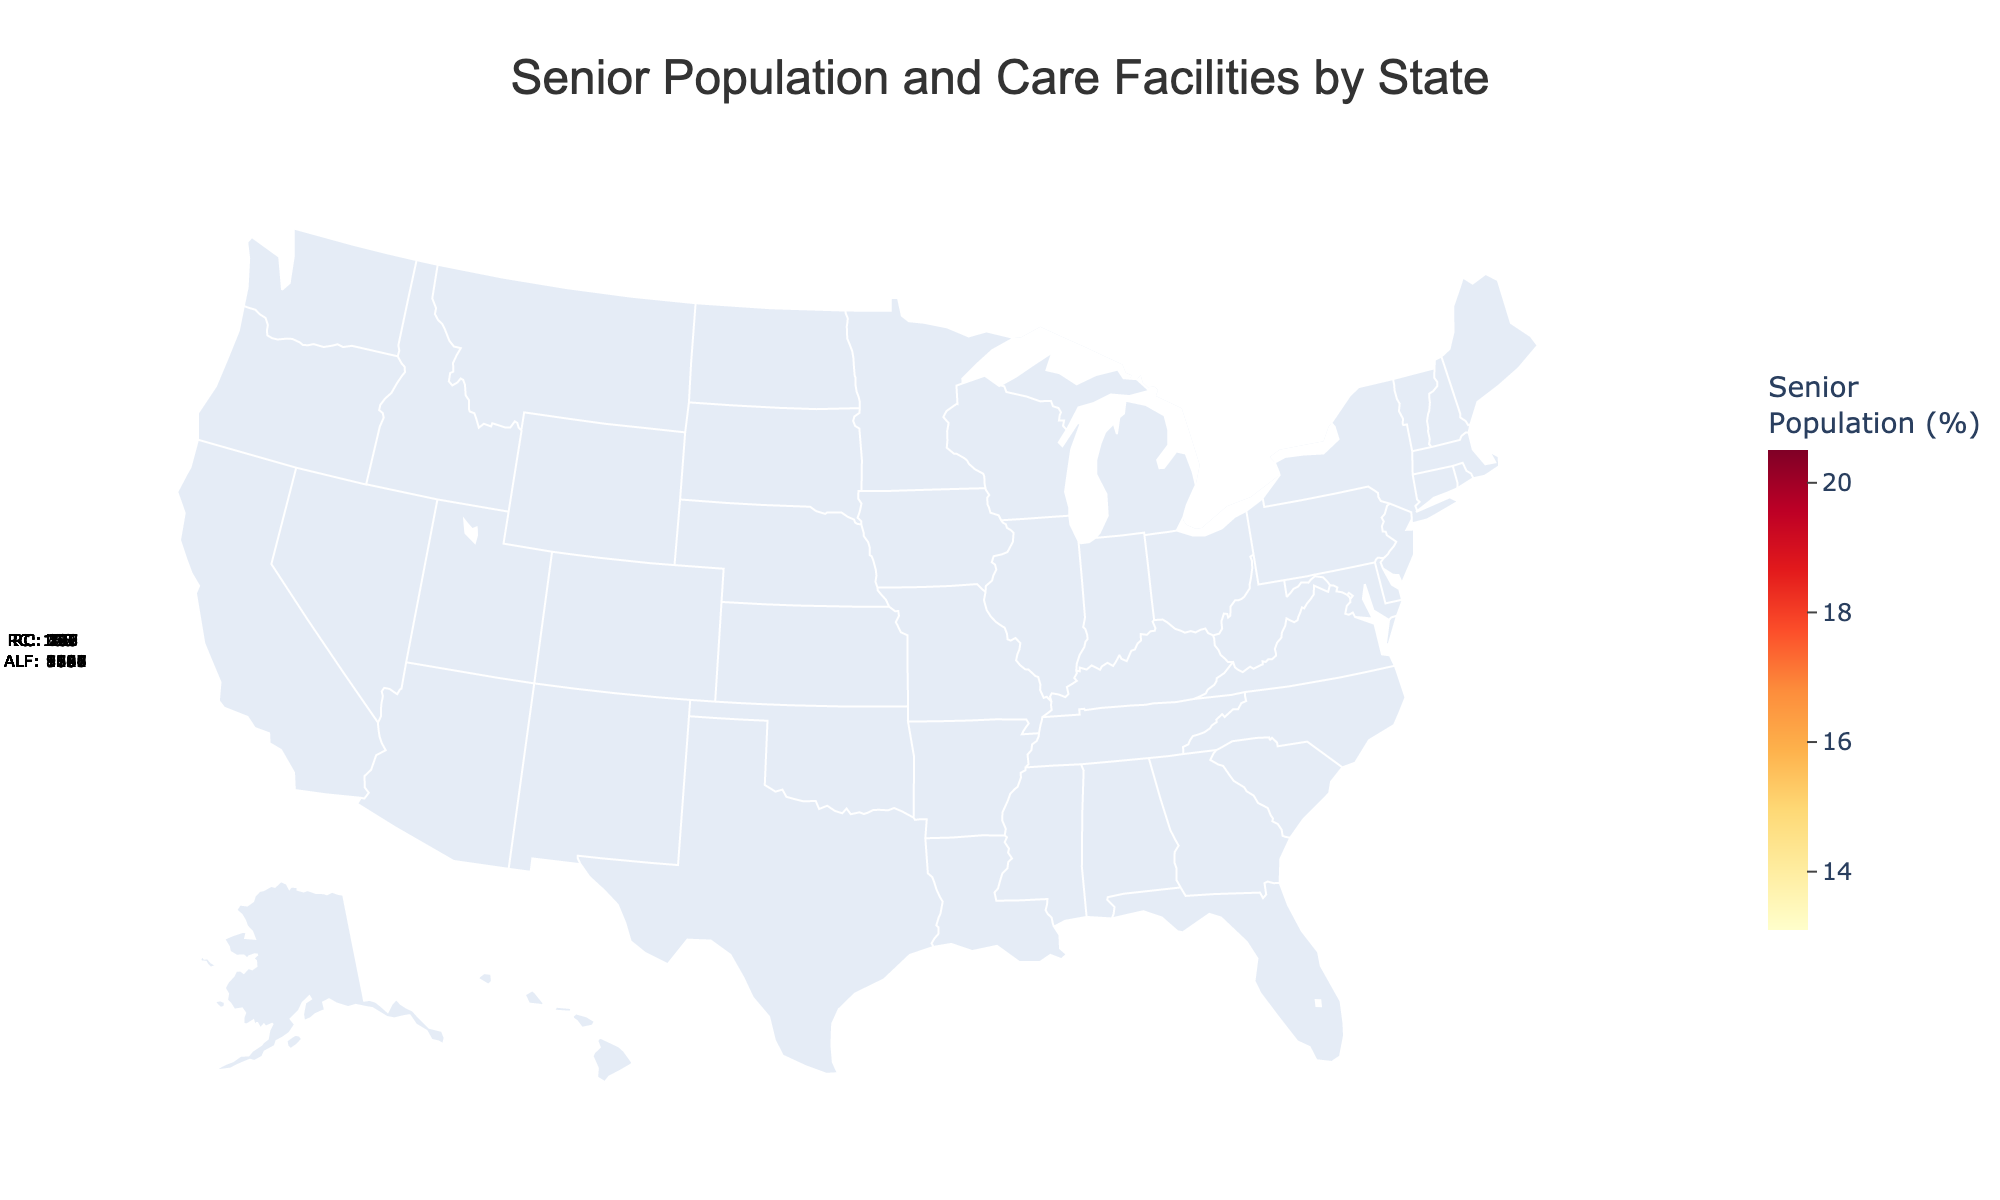what is the state with the highest senior population percentage? The figure shows that Florida has the highest senior population percentage among the listed states.
Answer: Florida How many assisted living facilities are there in New York? The figure's hover data reveals that New York has 1,105 assisted living facilities.
Answer: 1,105 What region has the lowest number of retirement communities? Based on the data presented, Oregon has the lowest number of retirement communities at 138.
Answer: Oregon What's the combined total of assisted living facilities in California and Texas? California has 3,021 assisted living facilities and Texas has 1,867. Adding them together gives 3,021 + 1,867 = 4,888.
Answer: 4,888 How does the senior population percentage compare between Florida and Texas? Florida has a senior population percentage of 20.5%, which is higher than Texas's 13.1%.
Answer: Florida > Texas Which region has a higher number of retirement communities, Pennsylvania or Arizona? Pennsylvania has 235 retirement communities, while Arizona has 198, so Pennsylvania has more.
Answer: Pennsylvania What state has the closest senior population percentage to 18%? Both Arizona and Oregon have a senior population percentage of 18.2%, which is the closest to 18%.
Answer: Arizona and Oregon How many regions have more than 1,000 assisted living facilities? The figure shows that California, Texas, Florida, Pennsylvania, New York, Ohio, Illinois, and Arizona each have more than 1,000 assisted living facilities, totaling 8 regions.
Answer: 8 Which regions have the same senior population percentage? By examining the figure, we see that Arizona and Oregon both have a senior population percentage of 18.2%, and Virginia and Washington both have 15.9%.
Answer: Arizona and Oregon, Virginia and Washington 